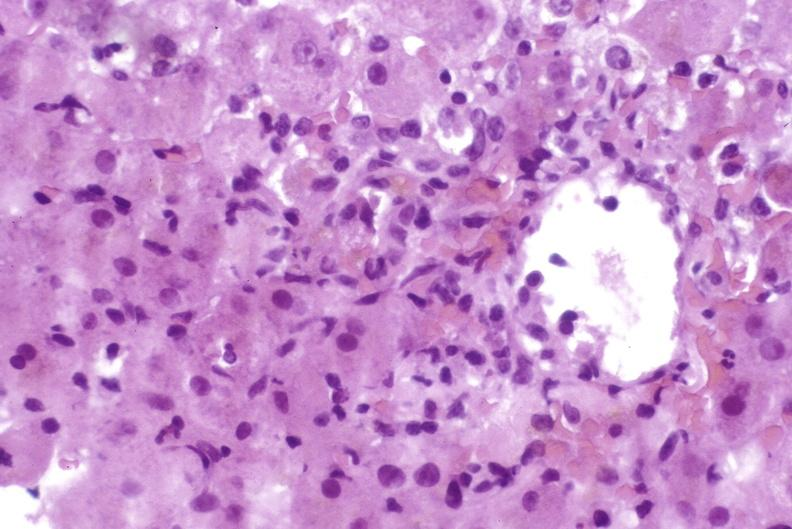s hand present?
Answer the question using a single word or phrase. No 